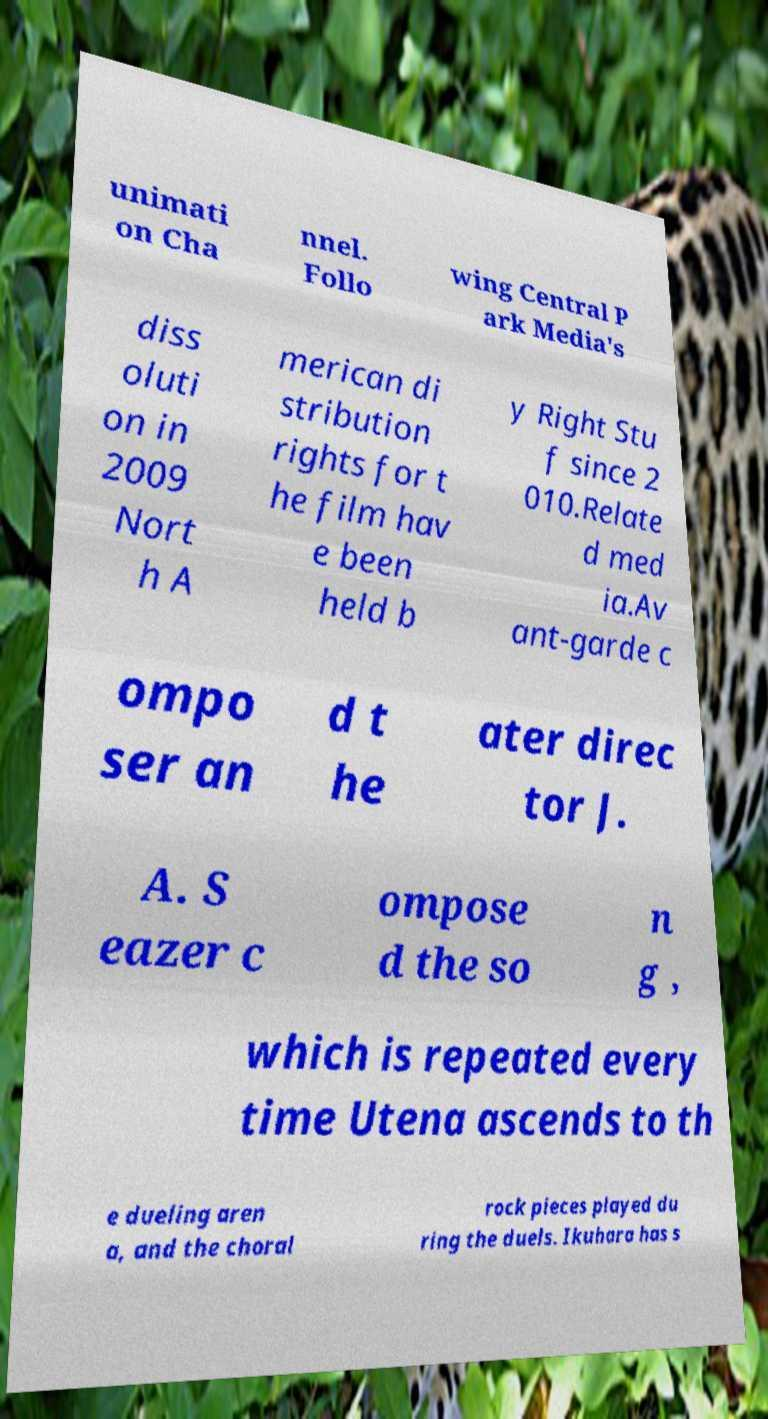Could you extract and type out the text from this image? unimati on Cha nnel. Follo wing Central P ark Media's diss oluti on in 2009 Nort h A merican di stribution rights for t he film hav e been held b y Right Stu f since 2 010.Relate d med ia.Av ant-garde c ompo ser an d t he ater direc tor J. A. S eazer c ompose d the so n g , which is repeated every time Utena ascends to th e dueling aren a, and the choral rock pieces played du ring the duels. Ikuhara has s 